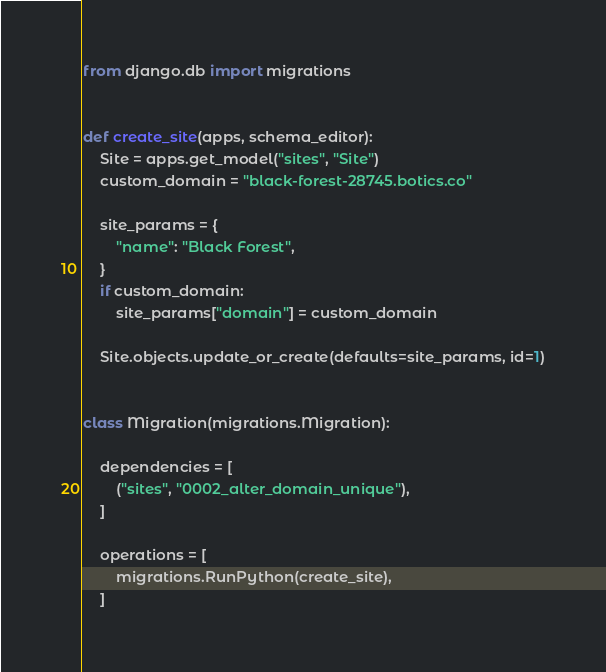<code> <loc_0><loc_0><loc_500><loc_500><_Python_>from django.db import migrations


def create_site(apps, schema_editor):
    Site = apps.get_model("sites", "Site")
    custom_domain = "black-forest-28745.botics.co"

    site_params = {
        "name": "Black Forest",
    }
    if custom_domain:
        site_params["domain"] = custom_domain

    Site.objects.update_or_create(defaults=site_params, id=1)


class Migration(migrations.Migration):

    dependencies = [
        ("sites", "0002_alter_domain_unique"),
    ]

    operations = [
        migrations.RunPython(create_site),
    ]
</code> 